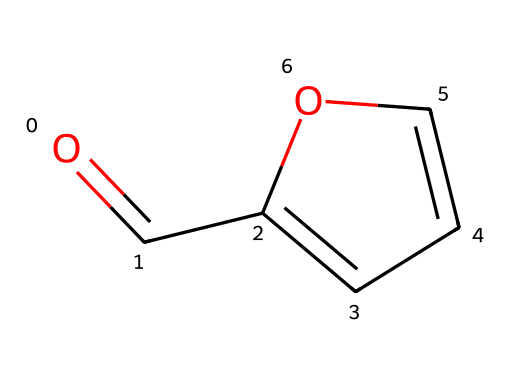What is the chemical name of this compound? The SMILES representation indicates the structure contains a carbonyl group (C=O) bonded to an alkene ring. This structure corresponds to furfural, which is the common name used for this specific aldehyde.
Answer: furfural How many carbon atoms are present in furfural? By analyzing the SMILES representation, there are five carbon atoms in total. The carbon atoms are indicated in various parts of the structure, including the carbonyl group.
Answer: five What is the functional group present in furfural? The chemical structure reveals a carbonyl group (C=O) at the end of the carbon chain, characteristic of aldehydes. This functional group is essential for identifying aldehydes.
Answer: aldehyde Does furfural contain a cyclic or acyclic structure? The SMILES representation shows a ring structure, indicated by the use of 'C1' and 'C=CO1', suggesting it is a cyclic compound.
Answer: cyclic What type of bonding is present between the oxygen and carbon atoms in the carbonyl group? In the carbonyl group of furfural, the bond between the oxygen and carbon is a double bond, as indicated by the '=' symbol in the SMILES representation.
Answer: double bond How many double bonds are present in furfural? The SMILES notation shows one double bond in the carbonyl group and one in the ring structure, totaling two double bonds in furfural.
Answer: two What role does furfural play in wood rosin treatments for opera house stages? Furfural is used primarily as a solvent and a reactant in various chemical processes, aiding in the treatment of wood rosin to enhance the durability and aesthetic properties of the stage materials.
Answer: solvent 